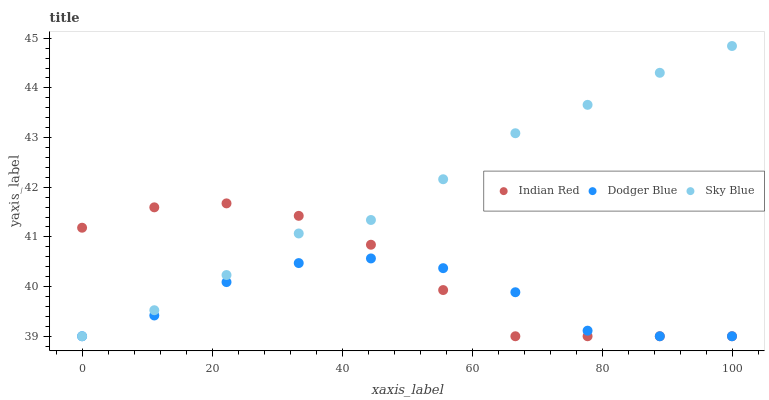Does Dodger Blue have the minimum area under the curve?
Answer yes or no. Yes. Does Sky Blue have the maximum area under the curve?
Answer yes or no. Yes. Does Indian Red have the minimum area under the curve?
Answer yes or no. No. Does Indian Red have the maximum area under the curve?
Answer yes or no. No. Is Sky Blue the smoothest?
Answer yes or no. Yes. Is Dodger Blue the roughest?
Answer yes or no. Yes. Is Indian Red the smoothest?
Answer yes or no. No. Is Indian Red the roughest?
Answer yes or no. No. Does Sky Blue have the lowest value?
Answer yes or no. Yes. Does Sky Blue have the highest value?
Answer yes or no. Yes. Does Indian Red have the highest value?
Answer yes or no. No. Does Indian Red intersect Sky Blue?
Answer yes or no. Yes. Is Indian Red less than Sky Blue?
Answer yes or no. No. Is Indian Red greater than Sky Blue?
Answer yes or no. No. 